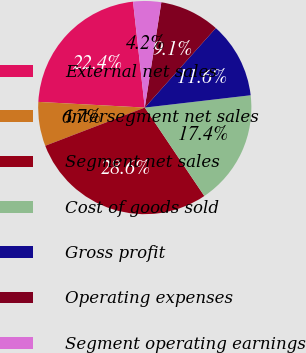Convert chart to OTSL. <chart><loc_0><loc_0><loc_500><loc_500><pie_chart><fcel>External net sales<fcel>Intersegment net sales<fcel>Segment net sales<fcel>Cost of goods sold<fcel>Gross profit<fcel>Operating expenses<fcel>Segment operating earnings<nl><fcel>22.39%<fcel>6.68%<fcel>28.6%<fcel>17.41%<fcel>11.55%<fcel>9.12%<fcel>4.24%<nl></chart> 